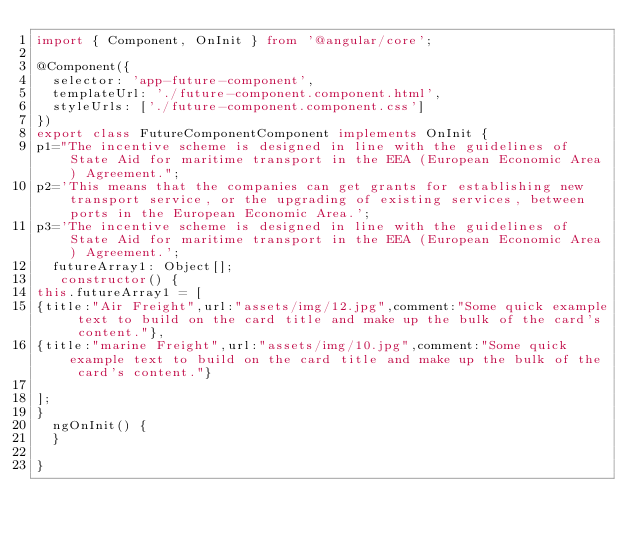<code> <loc_0><loc_0><loc_500><loc_500><_TypeScript_>import { Component, OnInit } from '@angular/core';

@Component({
  selector: 'app-future-component',
  templateUrl: './future-component.component.html',
  styleUrls: ['./future-component.component.css']
})
export class FutureComponentComponent implements OnInit {
p1="The incentive scheme is designed in line with the guidelines of State Aid for maritime transport in the EEA (European Economic Area) Agreement.";
p2='This means that the companies can get grants for establishing new transport service, or the upgrading of existing services, between ports in the European Economic Area.';
p3='The incentive scheme is designed in line with the guidelines of State Aid for maritime transport in the EEA (European Economic Area) Agreement.';
  futureArray1: Object[];
   constructor() {
this.futureArray1 = [
{title:"Air Freight",url:"assets/img/12.jpg",comment:"Some quick example text to build on the card title and make up the bulk of the card's content."},
{title:"marine Freight",url:"assets/img/10.jpg",comment:"Some quick example text to build on the card title and make up the bulk of the card's content."}

]; 
}
  ngOnInit() {
  }

}
</code> 